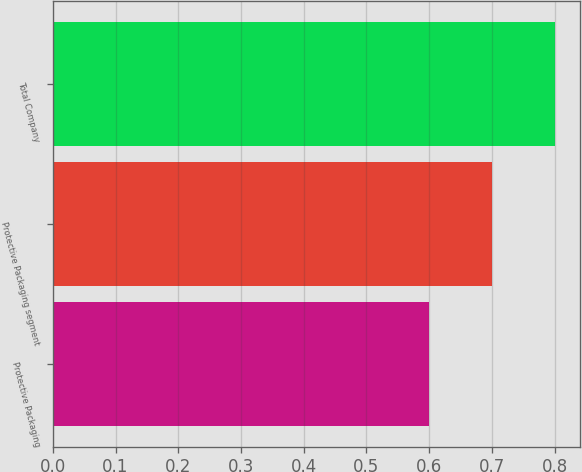Convert chart to OTSL. <chart><loc_0><loc_0><loc_500><loc_500><bar_chart><fcel>Protective Packaging<fcel>Protective Packaging segment<fcel>Total Company<nl><fcel>0.6<fcel>0.7<fcel>0.8<nl></chart> 